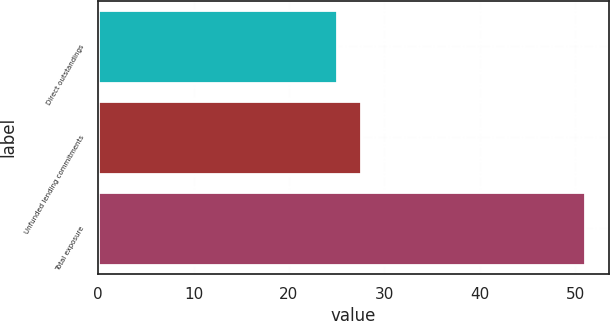Convert chart to OTSL. <chart><loc_0><loc_0><loc_500><loc_500><bar_chart><fcel>Direct outstandings<fcel>Unfunded lending commitments<fcel>Total exposure<nl><fcel>25<fcel>27.6<fcel>51<nl></chart> 